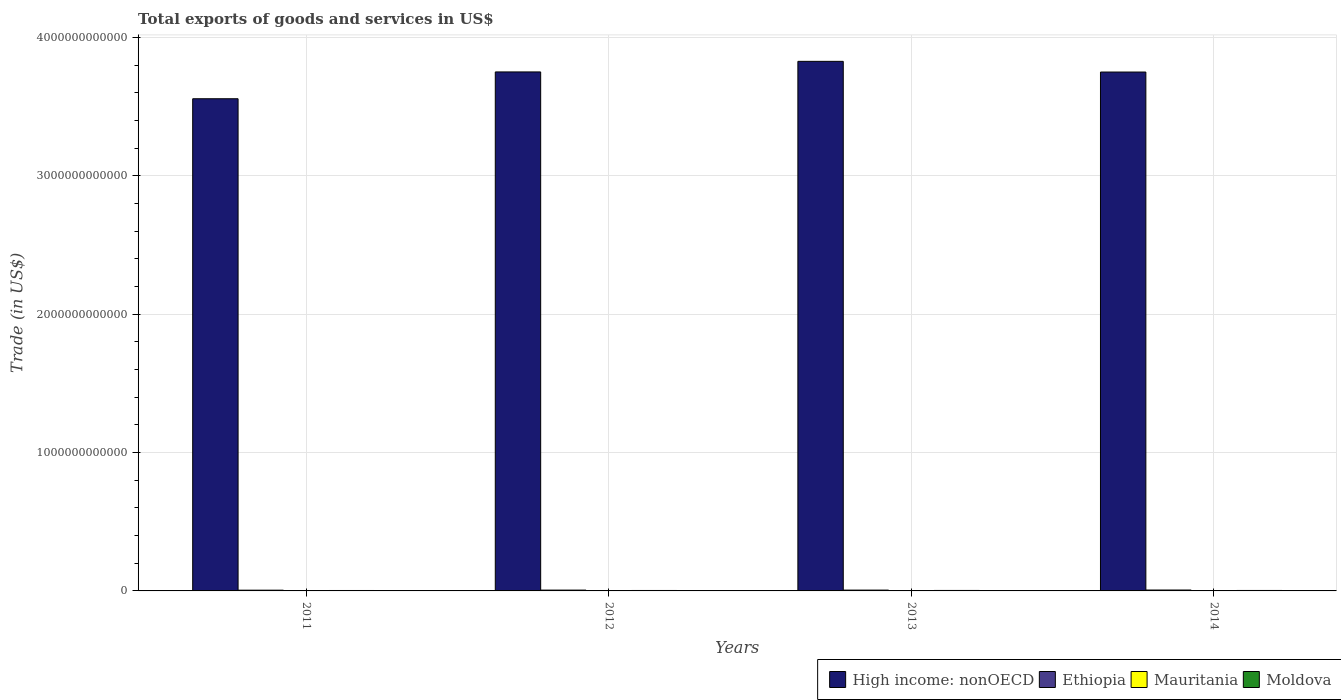How many groups of bars are there?
Your answer should be compact. 4. Are the number of bars per tick equal to the number of legend labels?
Your answer should be very brief. Yes. How many bars are there on the 4th tick from the right?
Keep it short and to the point. 4. What is the label of the 4th group of bars from the left?
Keep it short and to the point. 2014. What is the total exports of goods and services in High income: nonOECD in 2011?
Keep it short and to the point. 3.56e+12. Across all years, what is the maximum total exports of goods and services in Mauritania?
Keep it short and to the point. 2.99e+09. Across all years, what is the minimum total exports of goods and services in Ethiopia?
Offer a very short reply. 5.33e+09. What is the total total exports of goods and services in High income: nonOECD in the graph?
Make the answer very short. 1.49e+13. What is the difference between the total exports of goods and services in Ethiopia in 2011 and that in 2014?
Your answer should be compact. -1.14e+09. What is the difference between the total exports of goods and services in High income: nonOECD in 2011 and the total exports of goods and services in Mauritania in 2013?
Offer a terse response. 3.55e+12. What is the average total exports of goods and services in Ethiopia per year?
Ensure brevity in your answer.  5.93e+09. In the year 2014, what is the difference between the total exports of goods and services in Mauritania and total exports of goods and services in Moldova?
Keep it short and to the point. -8.96e+08. What is the ratio of the total exports of goods and services in High income: nonOECD in 2012 to that in 2013?
Your answer should be very brief. 0.98. What is the difference between the highest and the second highest total exports of goods and services in Moldova?
Keep it short and to the point. 1.46e+08. What is the difference between the highest and the lowest total exports of goods and services in Ethiopia?
Your answer should be very brief. 1.14e+09. Is the sum of the total exports of goods and services in Mauritania in 2012 and 2013 greater than the maximum total exports of goods and services in Moldova across all years?
Make the answer very short. Yes. What does the 3rd bar from the left in 2012 represents?
Keep it short and to the point. Mauritania. What does the 4th bar from the right in 2012 represents?
Your answer should be very brief. High income: nonOECD. Are all the bars in the graph horizontal?
Give a very brief answer. No. How many years are there in the graph?
Give a very brief answer. 4. What is the difference between two consecutive major ticks on the Y-axis?
Give a very brief answer. 1.00e+12. Are the values on the major ticks of Y-axis written in scientific E-notation?
Make the answer very short. No. Does the graph contain any zero values?
Make the answer very short. No. Does the graph contain grids?
Make the answer very short. Yes. Where does the legend appear in the graph?
Give a very brief answer. Bottom right. How are the legend labels stacked?
Provide a short and direct response. Horizontal. What is the title of the graph?
Give a very brief answer. Total exports of goods and services in US$. What is the label or title of the Y-axis?
Make the answer very short. Trade (in US$). What is the Trade (in US$) of High income: nonOECD in 2011?
Offer a very short reply. 3.56e+12. What is the Trade (in US$) in Ethiopia in 2011?
Offer a terse response. 5.33e+09. What is the Trade (in US$) of Mauritania in 2011?
Make the answer very short. 2.99e+09. What is the Trade (in US$) of Moldova in 2011?
Make the answer very short. 3.15e+09. What is the Trade (in US$) in High income: nonOECD in 2012?
Your answer should be very brief. 3.75e+12. What is the Trade (in US$) in Ethiopia in 2012?
Your answer should be compact. 5.96e+09. What is the Trade (in US$) of Mauritania in 2012?
Provide a succinct answer. 2.80e+09. What is the Trade (in US$) of Moldova in 2012?
Provide a short and direct response. 3.17e+09. What is the Trade (in US$) in High income: nonOECD in 2013?
Offer a terse response. 3.83e+12. What is the Trade (in US$) of Ethiopia in 2013?
Offer a very short reply. 5.95e+09. What is the Trade (in US$) in Mauritania in 2013?
Your response must be concise. 2.82e+09. What is the Trade (in US$) in Moldova in 2013?
Ensure brevity in your answer.  3.46e+09. What is the Trade (in US$) in High income: nonOECD in 2014?
Provide a short and direct response. 3.75e+12. What is the Trade (in US$) of Ethiopia in 2014?
Ensure brevity in your answer.  6.47e+09. What is the Trade (in US$) of Mauritania in 2014?
Your answer should be very brief. 2.42e+09. What is the Trade (in US$) in Moldova in 2014?
Offer a very short reply. 3.32e+09. Across all years, what is the maximum Trade (in US$) in High income: nonOECD?
Ensure brevity in your answer.  3.83e+12. Across all years, what is the maximum Trade (in US$) of Ethiopia?
Offer a terse response. 6.47e+09. Across all years, what is the maximum Trade (in US$) of Mauritania?
Keep it short and to the point. 2.99e+09. Across all years, what is the maximum Trade (in US$) of Moldova?
Provide a short and direct response. 3.46e+09. Across all years, what is the minimum Trade (in US$) in High income: nonOECD?
Offer a terse response. 3.56e+12. Across all years, what is the minimum Trade (in US$) in Ethiopia?
Your response must be concise. 5.33e+09. Across all years, what is the minimum Trade (in US$) in Mauritania?
Make the answer very short. 2.42e+09. Across all years, what is the minimum Trade (in US$) in Moldova?
Your response must be concise. 3.15e+09. What is the total Trade (in US$) in High income: nonOECD in the graph?
Your answer should be compact. 1.49e+13. What is the total Trade (in US$) in Ethiopia in the graph?
Make the answer very short. 2.37e+1. What is the total Trade (in US$) in Mauritania in the graph?
Give a very brief answer. 1.10e+1. What is the total Trade (in US$) of Moldova in the graph?
Provide a succinct answer. 1.31e+1. What is the difference between the Trade (in US$) in High income: nonOECD in 2011 and that in 2012?
Give a very brief answer. -1.94e+11. What is the difference between the Trade (in US$) of Ethiopia in 2011 and that in 2012?
Keep it short and to the point. -6.31e+08. What is the difference between the Trade (in US$) in Mauritania in 2011 and that in 2012?
Your answer should be compact. 1.84e+08. What is the difference between the Trade (in US$) in Moldova in 2011 and that in 2012?
Keep it short and to the point. -1.28e+07. What is the difference between the Trade (in US$) in High income: nonOECD in 2011 and that in 2013?
Ensure brevity in your answer.  -2.70e+11. What is the difference between the Trade (in US$) of Ethiopia in 2011 and that in 2013?
Offer a terse response. -6.17e+08. What is the difference between the Trade (in US$) in Mauritania in 2011 and that in 2013?
Offer a very short reply. 1.66e+08. What is the difference between the Trade (in US$) in Moldova in 2011 and that in 2013?
Your response must be concise. -3.06e+08. What is the difference between the Trade (in US$) in High income: nonOECD in 2011 and that in 2014?
Provide a succinct answer. -1.93e+11. What is the difference between the Trade (in US$) in Ethiopia in 2011 and that in 2014?
Give a very brief answer. -1.14e+09. What is the difference between the Trade (in US$) of Mauritania in 2011 and that in 2014?
Provide a short and direct response. 5.66e+08. What is the difference between the Trade (in US$) in Moldova in 2011 and that in 2014?
Provide a succinct answer. -1.61e+08. What is the difference between the Trade (in US$) of High income: nonOECD in 2012 and that in 2013?
Offer a very short reply. -7.64e+1. What is the difference between the Trade (in US$) of Ethiopia in 2012 and that in 2013?
Offer a terse response. 1.43e+07. What is the difference between the Trade (in US$) in Mauritania in 2012 and that in 2013?
Give a very brief answer. -1.80e+07. What is the difference between the Trade (in US$) of Moldova in 2012 and that in 2013?
Offer a terse response. -2.94e+08. What is the difference between the Trade (in US$) in High income: nonOECD in 2012 and that in 2014?
Make the answer very short. 7.85e+08. What is the difference between the Trade (in US$) of Ethiopia in 2012 and that in 2014?
Make the answer very short. -5.11e+08. What is the difference between the Trade (in US$) in Mauritania in 2012 and that in 2014?
Keep it short and to the point. 3.82e+08. What is the difference between the Trade (in US$) in Moldova in 2012 and that in 2014?
Keep it short and to the point. -1.48e+08. What is the difference between the Trade (in US$) of High income: nonOECD in 2013 and that in 2014?
Your answer should be compact. 7.72e+1. What is the difference between the Trade (in US$) of Ethiopia in 2013 and that in 2014?
Offer a terse response. -5.26e+08. What is the difference between the Trade (in US$) in Mauritania in 2013 and that in 2014?
Your answer should be compact. 4.00e+08. What is the difference between the Trade (in US$) of Moldova in 2013 and that in 2014?
Provide a succinct answer. 1.46e+08. What is the difference between the Trade (in US$) in High income: nonOECD in 2011 and the Trade (in US$) in Ethiopia in 2012?
Offer a very short reply. 3.55e+12. What is the difference between the Trade (in US$) of High income: nonOECD in 2011 and the Trade (in US$) of Mauritania in 2012?
Keep it short and to the point. 3.55e+12. What is the difference between the Trade (in US$) of High income: nonOECD in 2011 and the Trade (in US$) of Moldova in 2012?
Keep it short and to the point. 3.55e+12. What is the difference between the Trade (in US$) of Ethiopia in 2011 and the Trade (in US$) of Mauritania in 2012?
Offer a very short reply. 2.53e+09. What is the difference between the Trade (in US$) of Ethiopia in 2011 and the Trade (in US$) of Moldova in 2012?
Your answer should be very brief. 2.16e+09. What is the difference between the Trade (in US$) of Mauritania in 2011 and the Trade (in US$) of Moldova in 2012?
Keep it short and to the point. -1.82e+08. What is the difference between the Trade (in US$) of High income: nonOECD in 2011 and the Trade (in US$) of Ethiopia in 2013?
Give a very brief answer. 3.55e+12. What is the difference between the Trade (in US$) of High income: nonOECD in 2011 and the Trade (in US$) of Mauritania in 2013?
Offer a terse response. 3.55e+12. What is the difference between the Trade (in US$) of High income: nonOECD in 2011 and the Trade (in US$) of Moldova in 2013?
Your response must be concise. 3.55e+12. What is the difference between the Trade (in US$) in Ethiopia in 2011 and the Trade (in US$) in Mauritania in 2013?
Provide a short and direct response. 2.51e+09. What is the difference between the Trade (in US$) in Ethiopia in 2011 and the Trade (in US$) in Moldova in 2013?
Give a very brief answer. 1.87e+09. What is the difference between the Trade (in US$) of Mauritania in 2011 and the Trade (in US$) of Moldova in 2013?
Offer a very short reply. -4.76e+08. What is the difference between the Trade (in US$) of High income: nonOECD in 2011 and the Trade (in US$) of Ethiopia in 2014?
Keep it short and to the point. 3.55e+12. What is the difference between the Trade (in US$) of High income: nonOECD in 2011 and the Trade (in US$) of Mauritania in 2014?
Provide a succinct answer. 3.55e+12. What is the difference between the Trade (in US$) in High income: nonOECD in 2011 and the Trade (in US$) in Moldova in 2014?
Your response must be concise. 3.55e+12. What is the difference between the Trade (in US$) of Ethiopia in 2011 and the Trade (in US$) of Mauritania in 2014?
Offer a terse response. 2.91e+09. What is the difference between the Trade (in US$) in Ethiopia in 2011 and the Trade (in US$) in Moldova in 2014?
Ensure brevity in your answer.  2.02e+09. What is the difference between the Trade (in US$) in Mauritania in 2011 and the Trade (in US$) in Moldova in 2014?
Provide a succinct answer. -3.30e+08. What is the difference between the Trade (in US$) in High income: nonOECD in 2012 and the Trade (in US$) in Ethiopia in 2013?
Make the answer very short. 3.74e+12. What is the difference between the Trade (in US$) of High income: nonOECD in 2012 and the Trade (in US$) of Mauritania in 2013?
Ensure brevity in your answer.  3.75e+12. What is the difference between the Trade (in US$) of High income: nonOECD in 2012 and the Trade (in US$) of Moldova in 2013?
Ensure brevity in your answer.  3.75e+12. What is the difference between the Trade (in US$) in Ethiopia in 2012 and the Trade (in US$) in Mauritania in 2013?
Your response must be concise. 3.14e+09. What is the difference between the Trade (in US$) in Ethiopia in 2012 and the Trade (in US$) in Moldova in 2013?
Keep it short and to the point. 2.50e+09. What is the difference between the Trade (in US$) of Mauritania in 2012 and the Trade (in US$) of Moldova in 2013?
Give a very brief answer. -6.60e+08. What is the difference between the Trade (in US$) in High income: nonOECD in 2012 and the Trade (in US$) in Ethiopia in 2014?
Keep it short and to the point. 3.74e+12. What is the difference between the Trade (in US$) in High income: nonOECD in 2012 and the Trade (in US$) in Mauritania in 2014?
Offer a very short reply. 3.75e+12. What is the difference between the Trade (in US$) in High income: nonOECD in 2012 and the Trade (in US$) in Moldova in 2014?
Give a very brief answer. 3.75e+12. What is the difference between the Trade (in US$) of Ethiopia in 2012 and the Trade (in US$) of Mauritania in 2014?
Keep it short and to the point. 3.54e+09. What is the difference between the Trade (in US$) in Ethiopia in 2012 and the Trade (in US$) in Moldova in 2014?
Your answer should be compact. 2.65e+09. What is the difference between the Trade (in US$) of Mauritania in 2012 and the Trade (in US$) of Moldova in 2014?
Offer a terse response. -5.14e+08. What is the difference between the Trade (in US$) of High income: nonOECD in 2013 and the Trade (in US$) of Ethiopia in 2014?
Make the answer very short. 3.82e+12. What is the difference between the Trade (in US$) of High income: nonOECD in 2013 and the Trade (in US$) of Mauritania in 2014?
Your answer should be very brief. 3.82e+12. What is the difference between the Trade (in US$) in High income: nonOECD in 2013 and the Trade (in US$) in Moldova in 2014?
Give a very brief answer. 3.82e+12. What is the difference between the Trade (in US$) in Ethiopia in 2013 and the Trade (in US$) in Mauritania in 2014?
Make the answer very short. 3.53e+09. What is the difference between the Trade (in US$) of Ethiopia in 2013 and the Trade (in US$) of Moldova in 2014?
Your answer should be compact. 2.63e+09. What is the difference between the Trade (in US$) of Mauritania in 2013 and the Trade (in US$) of Moldova in 2014?
Your answer should be compact. -4.96e+08. What is the average Trade (in US$) in High income: nonOECD per year?
Offer a terse response. 3.72e+12. What is the average Trade (in US$) in Ethiopia per year?
Provide a succinct answer. 5.93e+09. What is the average Trade (in US$) in Mauritania per year?
Keep it short and to the point. 2.76e+09. What is the average Trade (in US$) in Moldova per year?
Offer a very short reply. 3.27e+09. In the year 2011, what is the difference between the Trade (in US$) of High income: nonOECD and Trade (in US$) of Ethiopia?
Make the answer very short. 3.55e+12. In the year 2011, what is the difference between the Trade (in US$) in High income: nonOECD and Trade (in US$) in Mauritania?
Make the answer very short. 3.55e+12. In the year 2011, what is the difference between the Trade (in US$) in High income: nonOECD and Trade (in US$) in Moldova?
Offer a very short reply. 3.55e+12. In the year 2011, what is the difference between the Trade (in US$) in Ethiopia and Trade (in US$) in Mauritania?
Provide a short and direct response. 2.35e+09. In the year 2011, what is the difference between the Trade (in US$) of Ethiopia and Trade (in US$) of Moldova?
Your response must be concise. 2.18e+09. In the year 2011, what is the difference between the Trade (in US$) of Mauritania and Trade (in US$) of Moldova?
Offer a terse response. -1.69e+08. In the year 2012, what is the difference between the Trade (in US$) of High income: nonOECD and Trade (in US$) of Ethiopia?
Keep it short and to the point. 3.74e+12. In the year 2012, what is the difference between the Trade (in US$) in High income: nonOECD and Trade (in US$) in Mauritania?
Provide a short and direct response. 3.75e+12. In the year 2012, what is the difference between the Trade (in US$) of High income: nonOECD and Trade (in US$) of Moldova?
Offer a terse response. 3.75e+12. In the year 2012, what is the difference between the Trade (in US$) in Ethiopia and Trade (in US$) in Mauritania?
Provide a short and direct response. 3.16e+09. In the year 2012, what is the difference between the Trade (in US$) of Ethiopia and Trade (in US$) of Moldova?
Your response must be concise. 2.80e+09. In the year 2012, what is the difference between the Trade (in US$) of Mauritania and Trade (in US$) of Moldova?
Make the answer very short. -3.66e+08. In the year 2013, what is the difference between the Trade (in US$) of High income: nonOECD and Trade (in US$) of Ethiopia?
Offer a very short reply. 3.82e+12. In the year 2013, what is the difference between the Trade (in US$) of High income: nonOECD and Trade (in US$) of Mauritania?
Make the answer very short. 3.82e+12. In the year 2013, what is the difference between the Trade (in US$) in High income: nonOECD and Trade (in US$) in Moldova?
Ensure brevity in your answer.  3.82e+12. In the year 2013, what is the difference between the Trade (in US$) in Ethiopia and Trade (in US$) in Mauritania?
Make the answer very short. 3.13e+09. In the year 2013, what is the difference between the Trade (in US$) of Ethiopia and Trade (in US$) of Moldova?
Keep it short and to the point. 2.49e+09. In the year 2013, what is the difference between the Trade (in US$) of Mauritania and Trade (in US$) of Moldova?
Your answer should be compact. -6.42e+08. In the year 2014, what is the difference between the Trade (in US$) of High income: nonOECD and Trade (in US$) of Ethiopia?
Make the answer very short. 3.74e+12. In the year 2014, what is the difference between the Trade (in US$) in High income: nonOECD and Trade (in US$) in Mauritania?
Give a very brief answer. 3.75e+12. In the year 2014, what is the difference between the Trade (in US$) in High income: nonOECD and Trade (in US$) in Moldova?
Make the answer very short. 3.75e+12. In the year 2014, what is the difference between the Trade (in US$) of Ethiopia and Trade (in US$) of Mauritania?
Give a very brief answer. 4.05e+09. In the year 2014, what is the difference between the Trade (in US$) of Ethiopia and Trade (in US$) of Moldova?
Ensure brevity in your answer.  3.16e+09. In the year 2014, what is the difference between the Trade (in US$) of Mauritania and Trade (in US$) of Moldova?
Provide a short and direct response. -8.96e+08. What is the ratio of the Trade (in US$) in High income: nonOECD in 2011 to that in 2012?
Your answer should be compact. 0.95. What is the ratio of the Trade (in US$) of Ethiopia in 2011 to that in 2012?
Your response must be concise. 0.89. What is the ratio of the Trade (in US$) of Mauritania in 2011 to that in 2012?
Provide a short and direct response. 1.07. What is the ratio of the Trade (in US$) in High income: nonOECD in 2011 to that in 2013?
Provide a short and direct response. 0.93. What is the ratio of the Trade (in US$) in Ethiopia in 2011 to that in 2013?
Provide a short and direct response. 0.9. What is the ratio of the Trade (in US$) of Mauritania in 2011 to that in 2013?
Provide a short and direct response. 1.06. What is the ratio of the Trade (in US$) of Moldova in 2011 to that in 2013?
Your answer should be very brief. 0.91. What is the ratio of the Trade (in US$) in High income: nonOECD in 2011 to that in 2014?
Keep it short and to the point. 0.95. What is the ratio of the Trade (in US$) in Ethiopia in 2011 to that in 2014?
Provide a succinct answer. 0.82. What is the ratio of the Trade (in US$) in Mauritania in 2011 to that in 2014?
Make the answer very short. 1.23. What is the ratio of the Trade (in US$) in Moldova in 2011 to that in 2014?
Your answer should be very brief. 0.95. What is the ratio of the Trade (in US$) in High income: nonOECD in 2012 to that in 2013?
Your answer should be compact. 0.98. What is the ratio of the Trade (in US$) of Moldova in 2012 to that in 2013?
Offer a very short reply. 0.92. What is the ratio of the Trade (in US$) of Ethiopia in 2012 to that in 2014?
Make the answer very short. 0.92. What is the ratio of the Trade (in US$) of Mauritania in 2012 to that in 2014?
Your response must be concise. 1.16. What is the ratio of the Trade (in US$) in Moldova in 2012 to that in 2014?
Provide a short and direct response. 0.96. What is the ratio of the Trade (in US$) in High income: nonOECD in 2013 to that in 2014?
Provide a short and direct response. 1.02. What is the ratio of the Trade (in US$) of Ethiopia in 2013 to that in 2014?
Give a very brief answer. 0.92. What is the ratio of the Trade (in US$) of Mauritania in 2013 to that in 2014?
Offer a very short reply. 1.17. What is the ratio of the Trade (in US$) of Moldova in 2013 to that in 2014?
Make the answer very short. 1.04. What is the difference between the highest and the second highest Trade (in US$) of High income: nonOECD?
Make the answer very short. 7.64e+1. What is the difference between the highest and the second highest Trade (in US$) in Ethiopia?
Ensure brevity in your answer.  5.11e+08. What is the difference between the highest and the second highest Trade (in US$) in Mauritania?
Give a very brief answer. 1.66e+08. What is the difference between the highest and the second highest Trade (in US$) in Moldova?
Offer a terse response. 1.46e+08. What is the difference between the highest and the lowest Trade (in US$) of High income: nonOECD?
Make the answer very short. 2.70e+11. What is the difference between the highest and the lowest Trade (in US$) of Ethiopia?
Your response must be concise. 1.14e+09. What is the difference between the highest and the lowest Trade (in US$) of Mauritania?
Keep it short and to the point. 5.66e+08. What is the difference between the highest and the lowest Trade (in US$) of Moldova?
Give a very brief answer. 3.06e+08. 